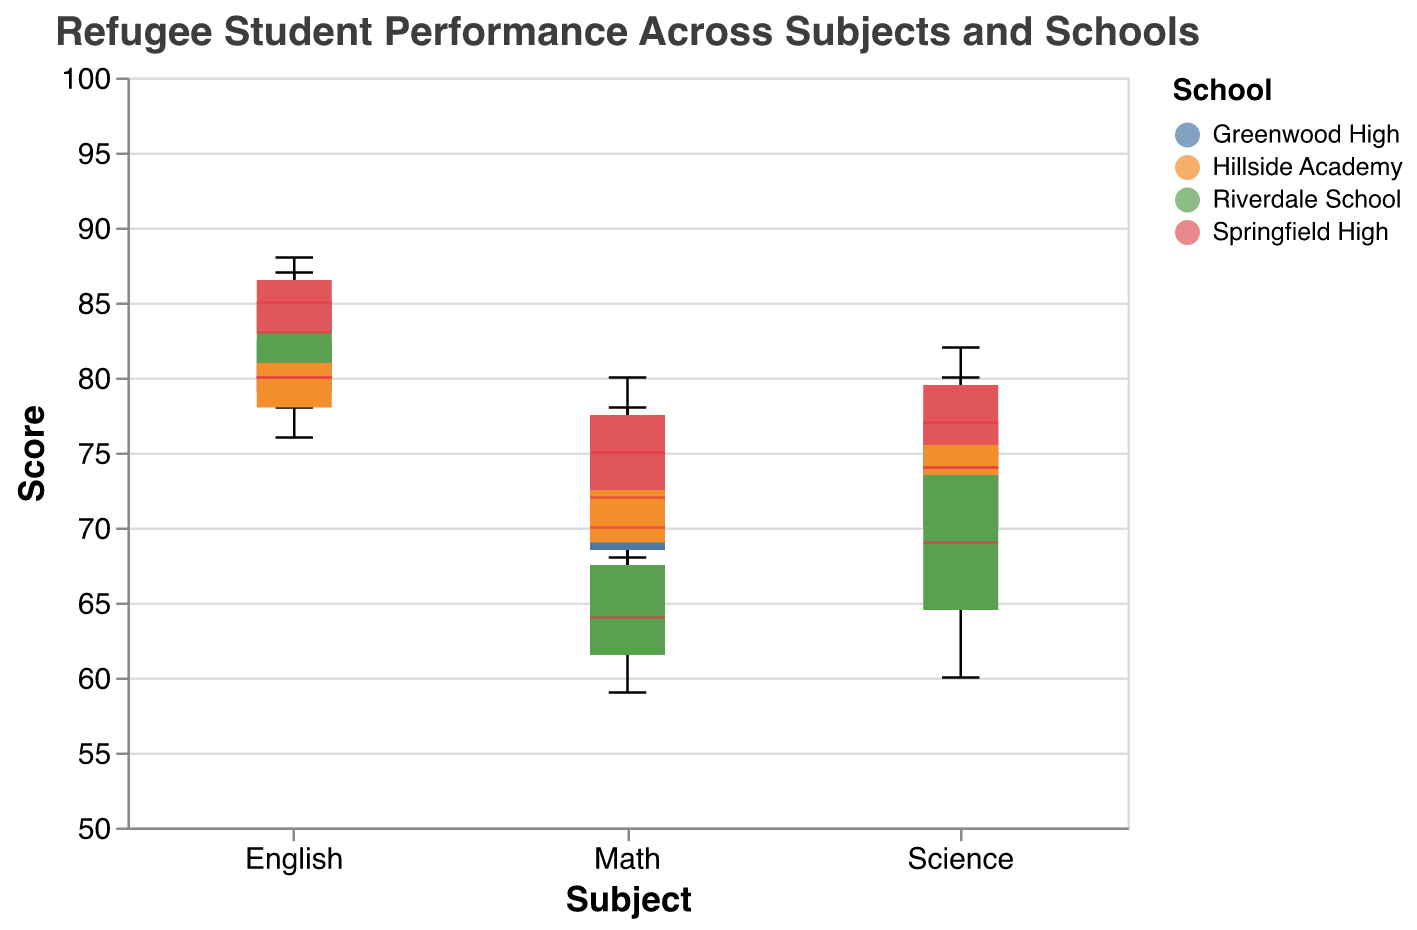What is the range of scores for refugee students in Math across all schools? To identify the range, find the minimum and maximum scores for Math in the boxplots. For Math, the minimum score is 59 (Riverdale School) and the maximum score is 80 (Springfield High).
Answer: 59 to 80 What is the median score for English at Springfield High? The median is the central value of the box plot for English at Springfield High. In this case, the median score is 85.
Answer: 85 Which subject shows the greatest variability in scores for refugee students at Greenwood High? Variability can be seen through the length of the interquartile range (IQR) in the box plot. For Greenwood High, comparing the ranges of Math, Science, and English, Math has the smallest variability and the other subjects are comparable. Therefore, more detailed analysis is needed, but English might appear slightly more variable.
Answer: English How do the Science scores of refugee students at Riverdale School compare to those at Hillside Academy? Compare the central points (median) and spread (interquartile range) of the Science scores box plots between the two schools. Riverdale School shows more spread, indicating greater variability, but both schools have similar medians around the mid-70s.
Answer: Similar medians, more variability at Riverdale School Which school has the highest median score for refugee students in English? Identify the central line (median) within the English box plots for each school. Springfield High has the highest median score at 85 for English.
Answer: Springfield High 